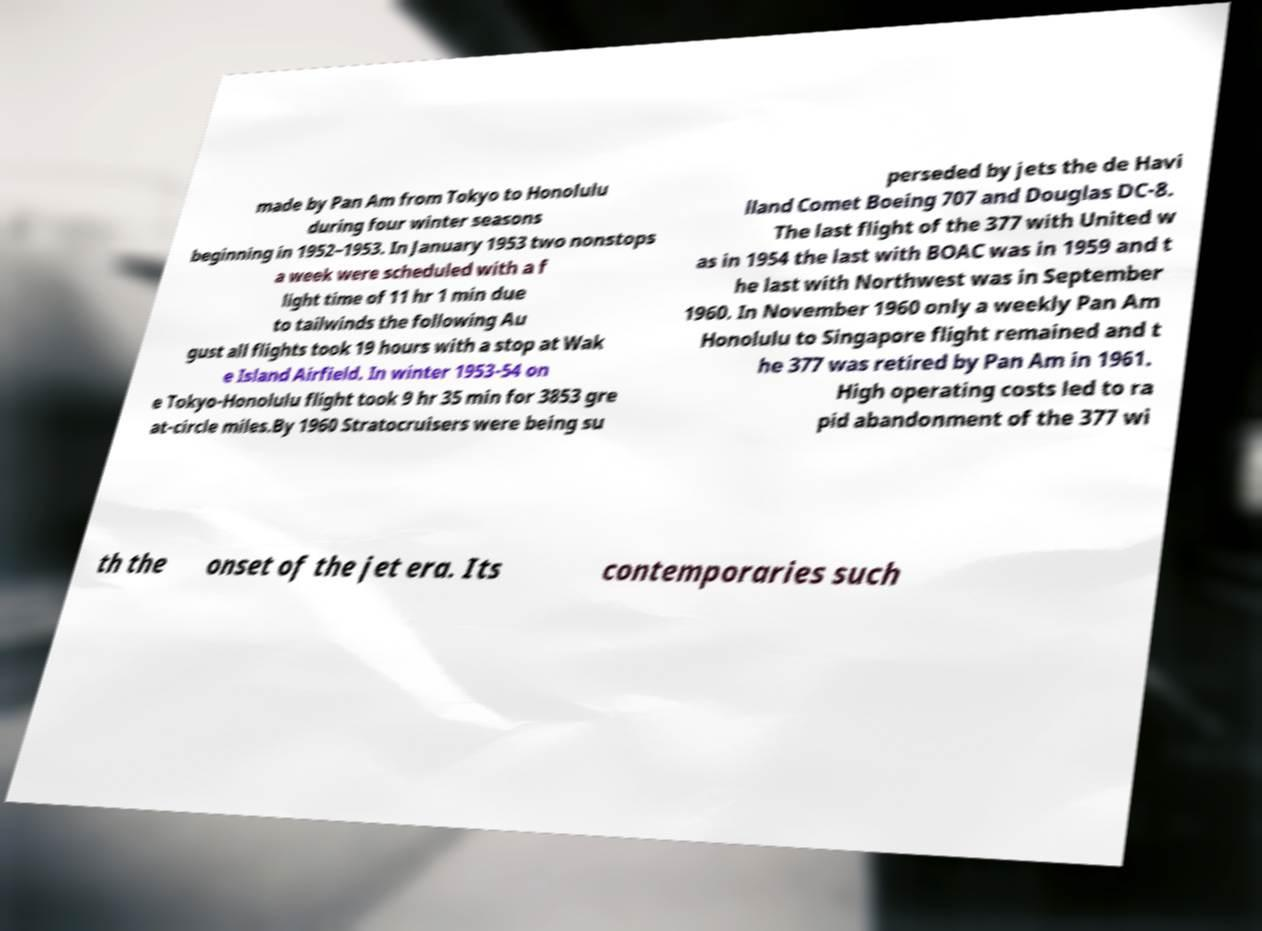Can you read and provide the text displayed in the image?This photo seems to have some interesting text. Can you extract and type it out for me? made by Pan Am from Tokyo to Honolulu during four winter seasons beginning in 1952–1953. In January 1953 two nonstops a week were scheduled with a f light time of 11 hr 1 min due to tailwinds the following Au gust all flights took 19 hours with a stop at Wak e Island Airfield. In winter 1953-54 on e Tokyo-Honolulu flight took 9 hr 35 min for 3853 gre at-circle miles.By 1960 Stratocruisers were being su perseded by jets the de Havi lland Comet Boeing 707 and Douglas DC-8. The last flight of the 377 with United w as in 1954 the last with BOAC was in 1959 and t he last with Northwest was in September 1960. In November 1960 only a weekly Pan Am Honolulu to Singapore flight remained and t he 377 was retired by Pan Am in 1961. High operating costs led to ra pid abandonment of the 377 wi th the onset of the jet era. Its contemporaries such 